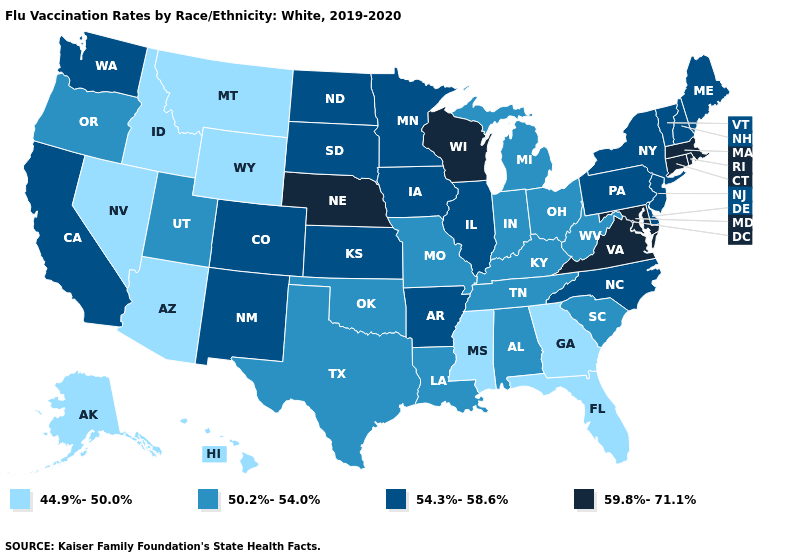Does the first symbol in the legend represent the smallest category?
Be succinct. Yes. Does Idaho have the highest value in the USA?
Keep it brief. No. How many symbols are there in the legend?
Keep it brief. 4. What is the highest value in the Northeast ?
Short answer required. 59.8%-71.1%. Does Massachusetts have the highest value in the USA?
Keep it brief. Yes. What is the value of Illinois?
Write a very short answer. 54.3%-58.6%. Name the states that have a value in the range 44.9%-50.0%?
Concise answer only. Alaska, Arizona, Florida, Georgia, Hawaii, Idaho, Mississippi, Montana, Nevada, Wyoming. Name the states that have a value in the range 50.2%-54.0%?
Short answer required. Alabama, Indiana, Kentucky, Louisiana, Michigan, Missouri, Ohio, Oklahoma, Oregon, South Carolina, Tennessee, Texas, Utah, West Virginia. Name the states that have a value in the range 59.8%-71.1%?
Short answer required. Connecticut, Maryland, Massachusetts, Nebraska, Rhode Island, Virginia, Wisconsin. Among the states that border Illinois , does Kentucky have the lowest value?
Be succinct. Yes. Name the states that have a value in the range 50.2%-54.0%?
Give a very brief answer. Alabama, Indiana, Kentucky, Louisiana, Michigan, Missouri, Ohio, Oklahoma, Oregon, South Carolina, Tennessee, Texas, Utah, West Virginia. Among the states that border Minnesota , which have the lowest value?
Short answer required. Iowa, North Dakota, South Dakota. What is the value of Kansas?
Concise answer only. 54.3%-58.6%. What is the lowest value in the South?
Concise answer only. 44.9%-50.0%. Among the states that border Wyoming , does South Dakota have the highest value?
Answer briefly. No. 